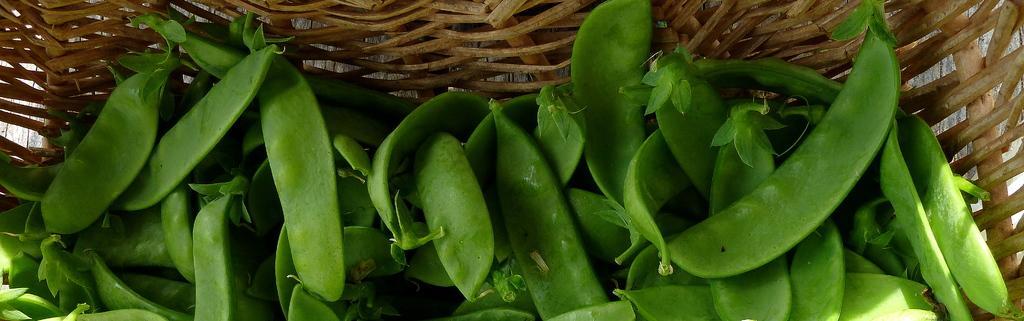Describe this image in one or two sentences. In this image I can see vegetables and wooden bowl 